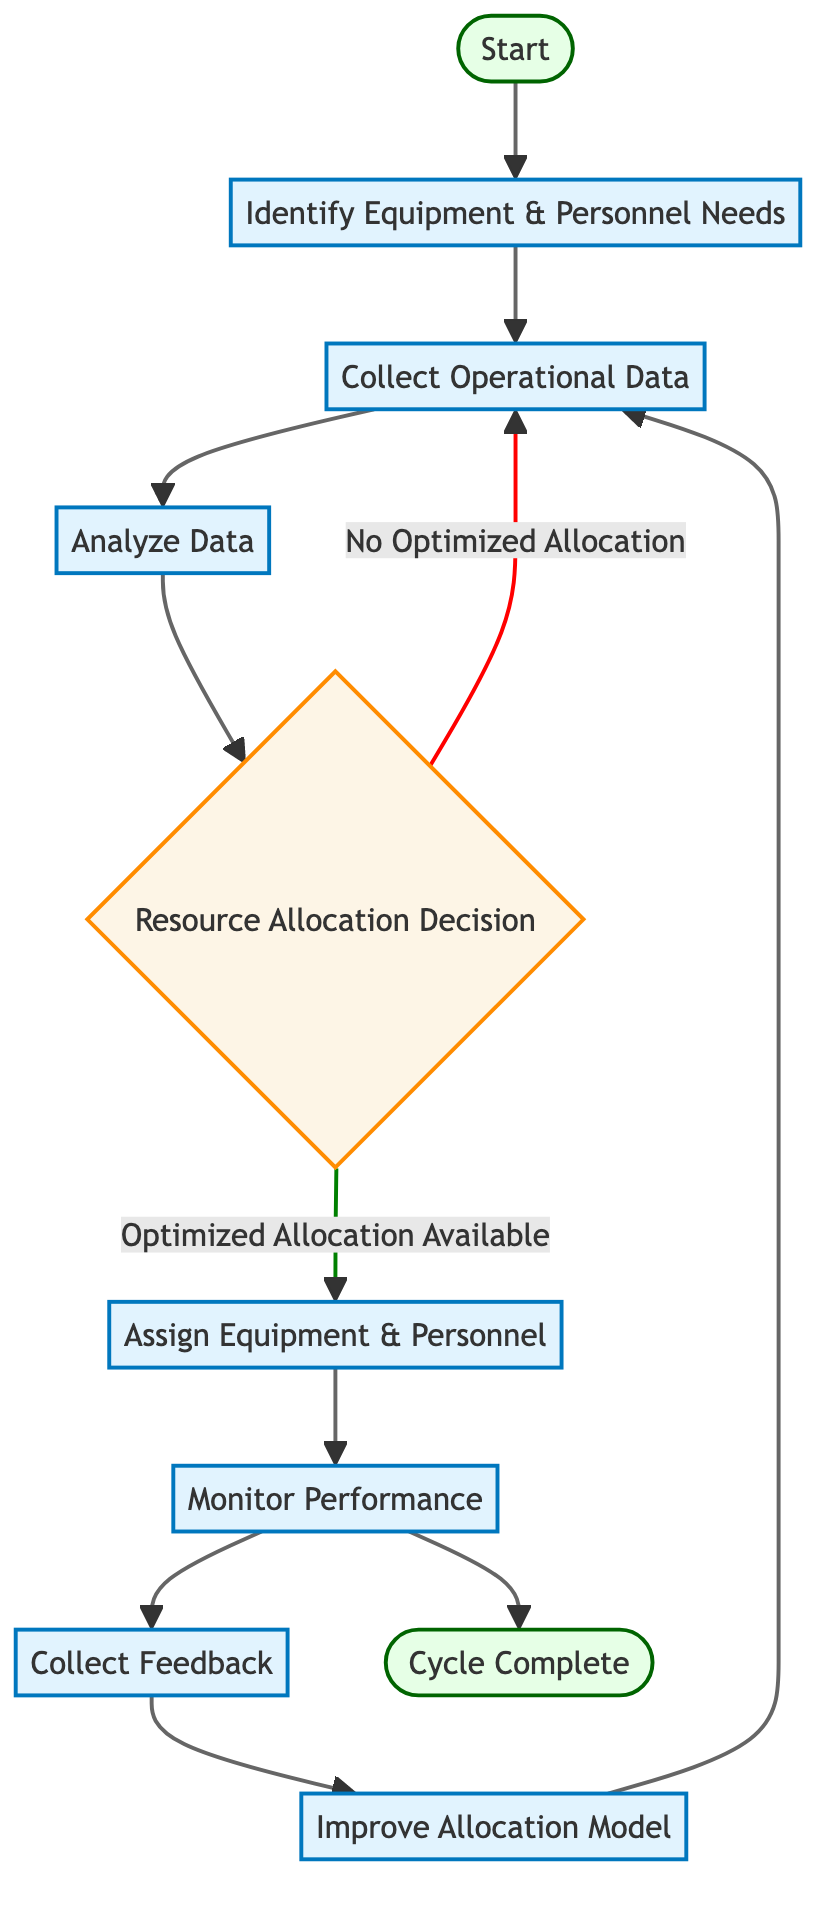What is the first step in the process? The first step in the process as indicated by the diagram is "Identify Equipment & Personnel Needs". This is the first node connected directly from the "Start" node.
Answer: Identify Equipment & Personnel Needs How many process nodes are in the diagram? To determine the number of process nodes, we count all nodes labeled with "process". There are 6 process nodes in total: "Identify Equipment & Personnel Needs", "Collect Operational Data", "Analyze Data", "Assign Equipment & Personnel", "Monitor Performance", and "Collect Feedback".
Answer: 6 What happens if there is no optimized allocation available? If there is no optimized allocation available, the flow returns to the "Collect Operational Data" node. This is shown as an outgoing connection labeled "No Optimized Allocation" that leads back to "Collect Operational Data".
Answer: Collect Operational Data What is the last action before completing the cycle? The last action before completing the cycle is "Monitor Performance", where the results of the operations are tracked. After this step, the flow can either lead to "Collect Feedback" or to "Cycle Complete" based on different paths in the diagram.
Answer: Monitor Performance What is the purpose of the "Improve Allocation Model" step? The purpose of the "Improve Allocation Model" step is to update the allocation models based on feedback and performance data. This node modifies the existing models to enhance future resource allocation based on collected feedback.
Answer: Update models based on feedback What is the role of the "Collect Feedback" node in the process? The "Collect Feedback" node serves to gather insights from personnel regarding operational efficiency. This feedback is essential for informing the "Improve Allocation Model" step. Thus, it is a critical component for continuous improvement within the cycle.
Answer: Gather feedback from personnel How does the process flow if optimized allocation is available? If optimized allocation is available, the process flows from the "Resource Allocation Decision" node to the "Assign Equipment & Personnel" node. This means that when resources are allocated optimally, the next logical step is to assign equipment and personnel accordingly.
Answer: Assign Equipment & Personnel What indicates a transition to the end of the cycle? A transition to the end of the cycle is indicated by the connection from "Monitor Performance" to the "Cycle Complete" node. This shows that the performance monitoring step can lead directly to the end conclusion, marking the completion of the operational cycle.
Answer: Cycle Complete 